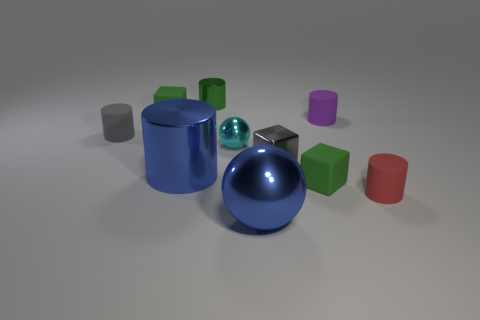Can you tell me if there are more cubes than cylinders in this image? Upon inspection, it appears there are five cube-shaped objects and three cylindrical objects in the scene, indicating there are indeed more cubes than cylinders. 